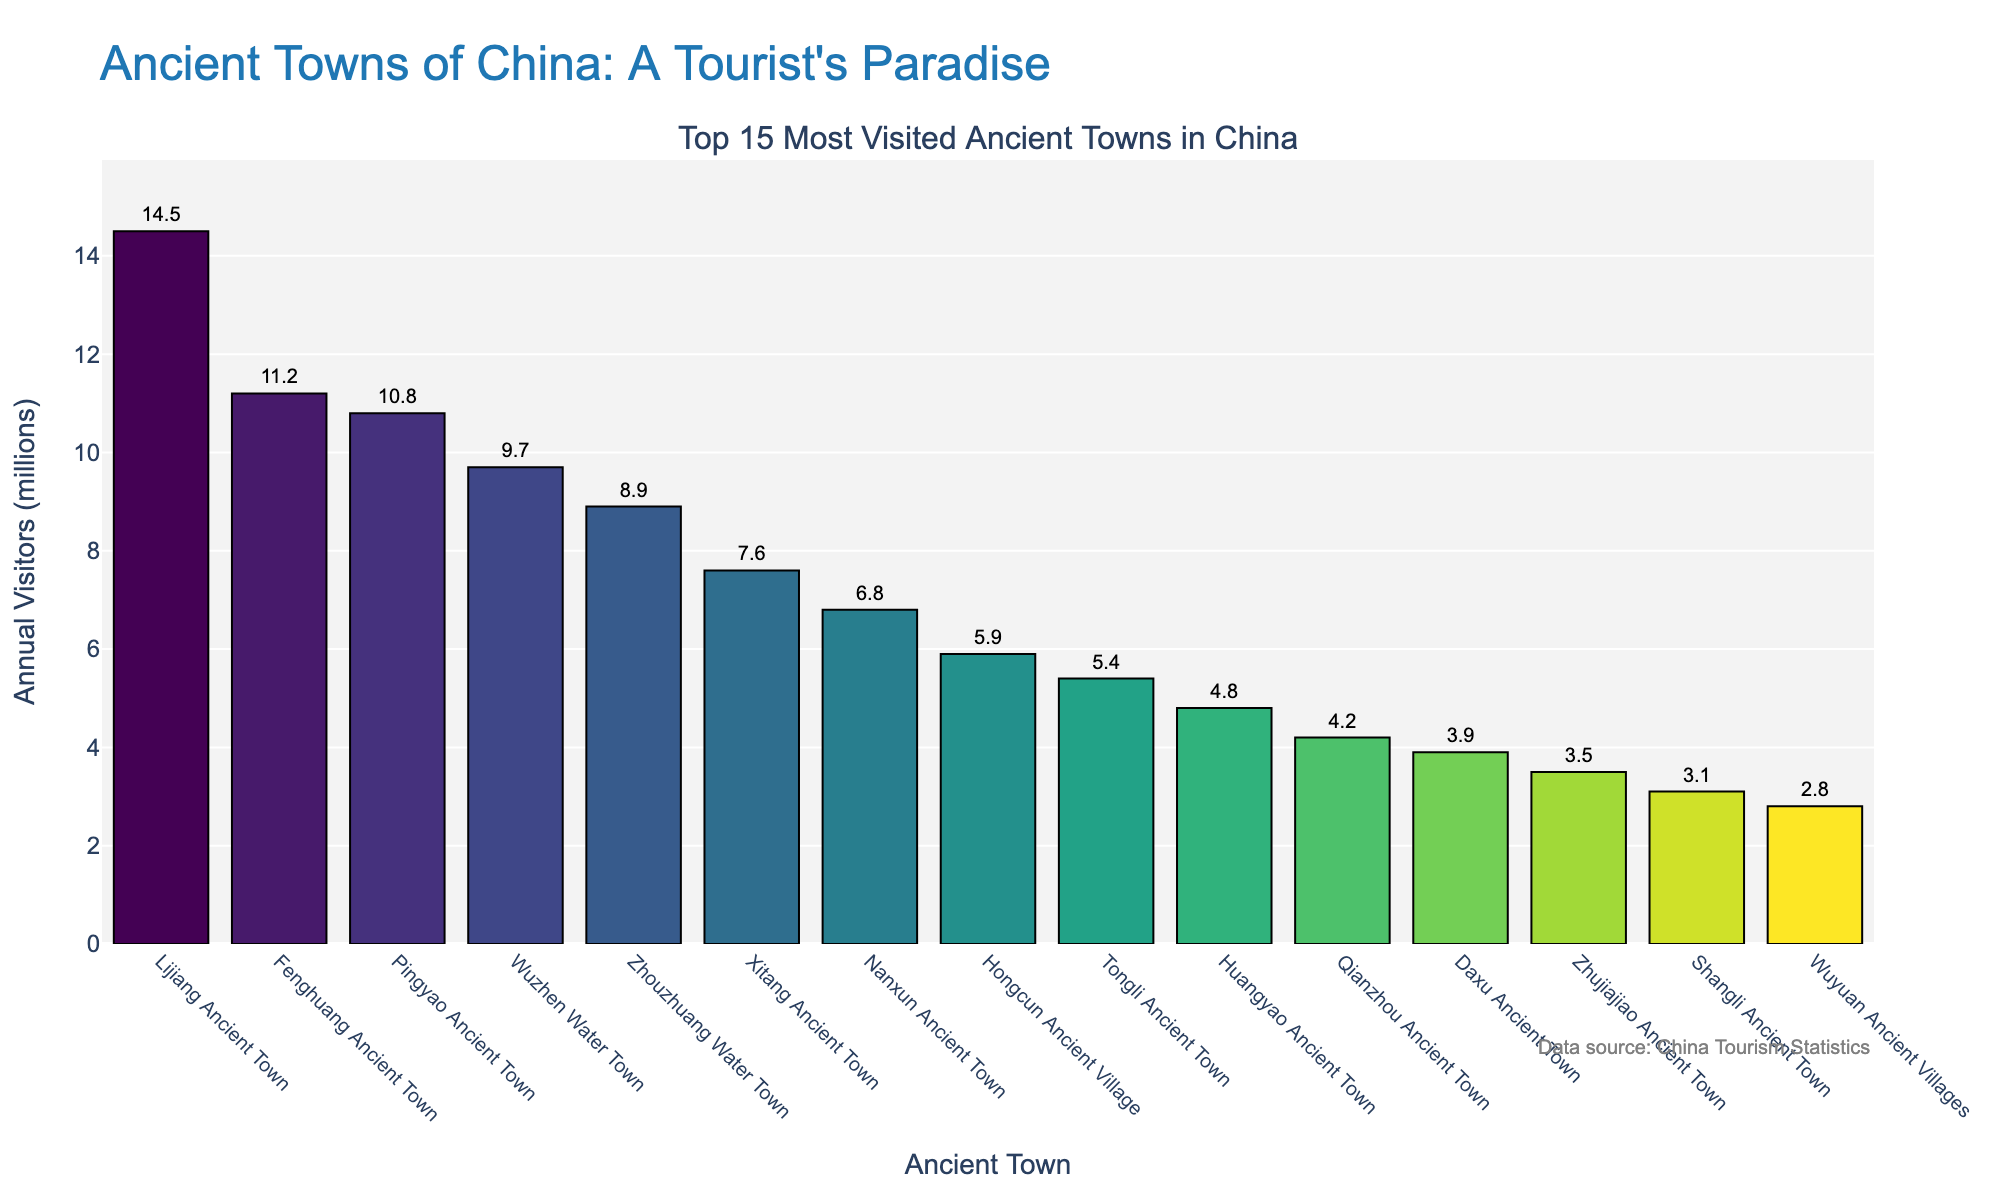How many ancient towns are listed in the chart? The figure title mentions "Top 15 Most Visited Ancient Towns" and counting the bars in the figure confirms there are 15 bars, each representing a different ancient town.
Answer: 15 What is the title of the bar chart? The chart's title is located at the top of the figure.
Answer: Ancient Towns of China: A Tourist's Paradise Which ancient town has the highest number of annual visitors? Looking at the tallest bar in the figure, which represents the town with the highest value on the y-axis.
Answer: Lijiang Ancient Town How many visitors did Fenghuang Ancient Town receive annually? Find the bar corresponding to Fenghuang Ancient Town and read its value.
Answer: 11.2 million What is the difference in annual visitors between Lijiang Ancient Town and Huangyao Ancient Town? Subtract the number of annual visitors to Huangyao Ancient Town from the number of annual visitors to Lijiang Ancient Town.
Answer: 14.5 million - 4.8 million = 9.7 million Order the top three most visited ancient towns by tourist numbers. Identify the towns with the three tallest bars and sort them in descending order of their heights.
Answer: Lijiang Ancient Town, Fenghuang Ancient Town, Pingyao Ancient Town What are the colors used in the chart to differentiate the bars? The bars are colored using a gradient from dark to light, based on a 'Viridis' color scale as observed from left to right.
Answer: Gradient of dark to light shades Which towns have fewer than 5 million annual visitors? Inspect the bars on the chart whose height falls under the 5 million mark on the y-axis.
Answer: Qianzhou Ancient Town, Daxu Ancient Town, Zhujiajiao Ancient Town, Shangli Ancient Town, Wuyuan Ancient Villages What's the combined total of annual visitors for the top 5 most visited towns? Sum the visitor numbers for the top 5 towns based on their bar heights: Lijiang Ancient Town (14.5), Fenghuang Ancient Town (11.2), Pingyao Ancient Town (10.8), Wuzhen Water Town (9.7), Zhouzhuang Water Town (8.9).
Answer: 14.5 + 11.2 + 10.8 + 9.7 + 8.9 = 55.1 million 